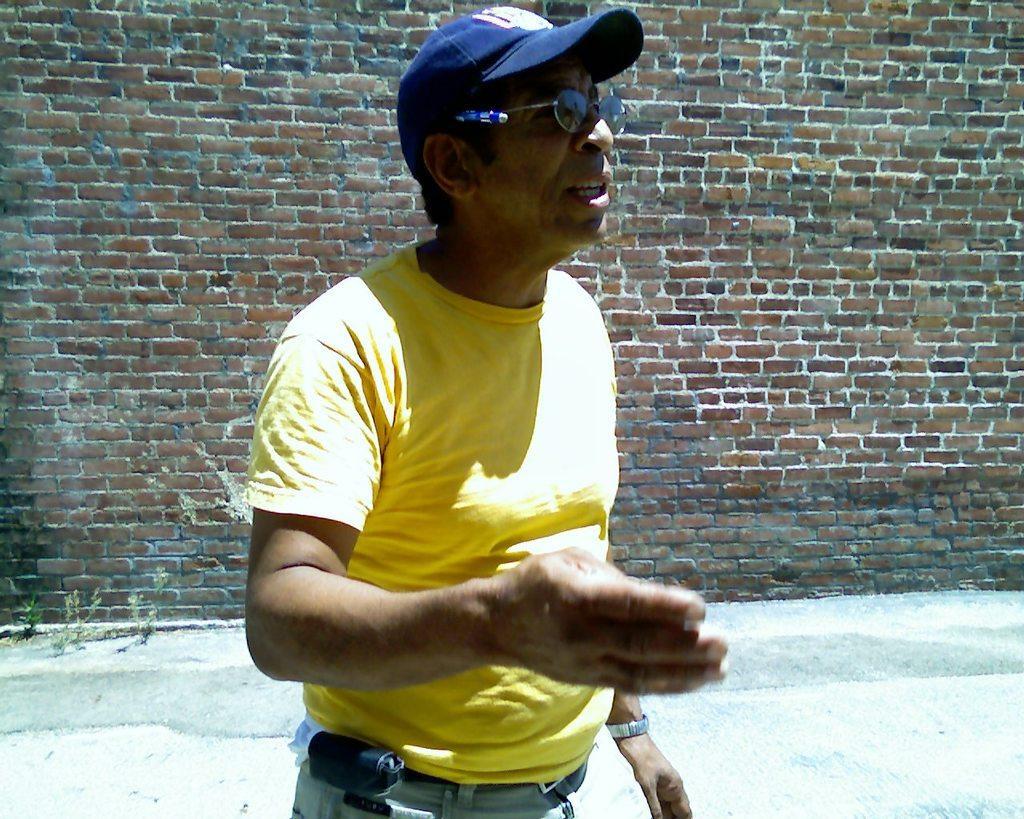Could you give a brief overview of what you see in this image? In the center of the image a man is standing and wearing a hat. In the background of the image a wall is there. At the bottom of the image ground is present. 